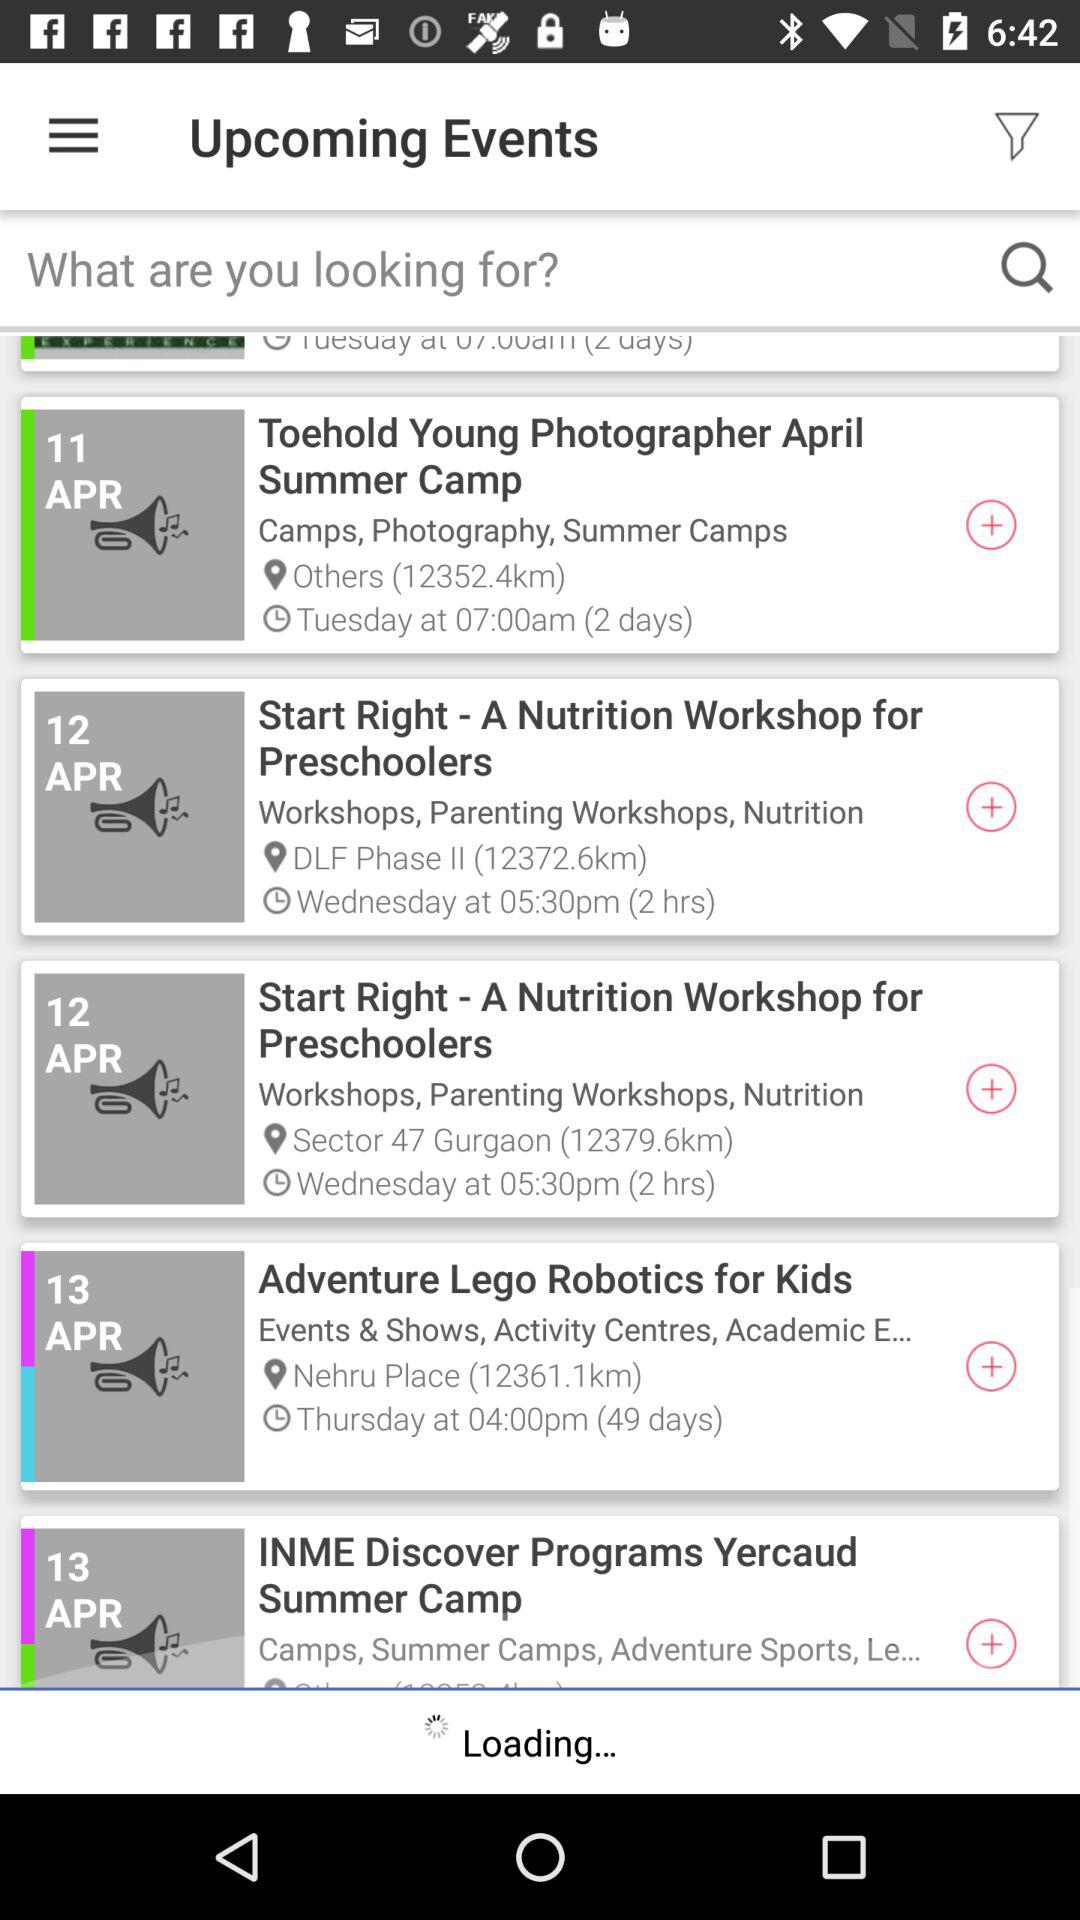How long will the event "Adventure Lego Robotics for Kids" last? The event will last for 49 days. 